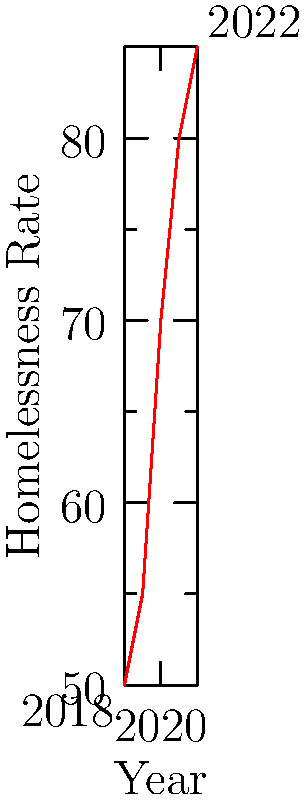The graph shows the homelessness rate in a city from 2018 to 2022. Considering this as a vector from the starting point (2018, 50) to the ending point (2022, 85), calculate the magnitude of this vector representing the change in homelessness over this period. To calculate the magnitude of the vector, we need to follow these steps:

1. Identify the components of the vector:
   x-component (change in years): 2022 - 2018 = 4 years
   y-component (change in homelessness rate): 85 - 50 = 35 per 100,000 population

2. Use the Pythagorean theorem to calculate the magnitude:
   Let's call the magnitude |v|.
   
   $$|v| = \sqrt{(\Delta x)^2 + (\Delta y)^2}$$
   
   Where Δx is the change in x and Δy is the change in y.

3. Substitute the values:
   $$|v| = \sqrt{(4)^2 + (35)^2}$$

4. Calculate:
   $$|v| = \sqrt{16 + 1225} = \sqrt{1241} \approx 35.23$$

5. Round to two decimal places:
   |v| ≈ 35.23

The units of this magnitude are a combination of years and homelessness rate, which doesn't have a straightforward interpretation. However, it represents the overall change considering both time and homelessness rate increase.
Answer: 35.23 